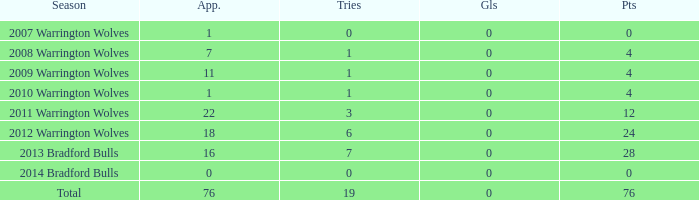What is the sum of appearance when goals is more than 0? None. 